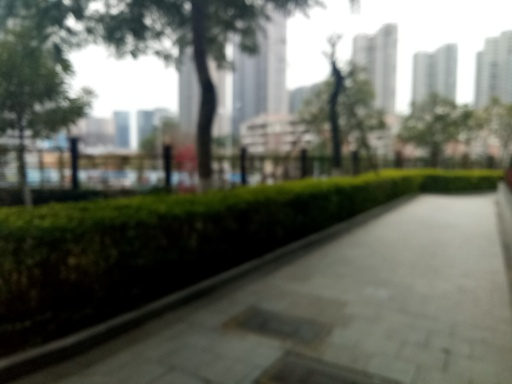What kind of weather conditions are implied by the image? The overcast sky and lack of harsh shadows suggest that the weather conditions might be cloudy. There seems to be an absence of rain at the time the photograph was taken because the paths and plants don't appear wet. 